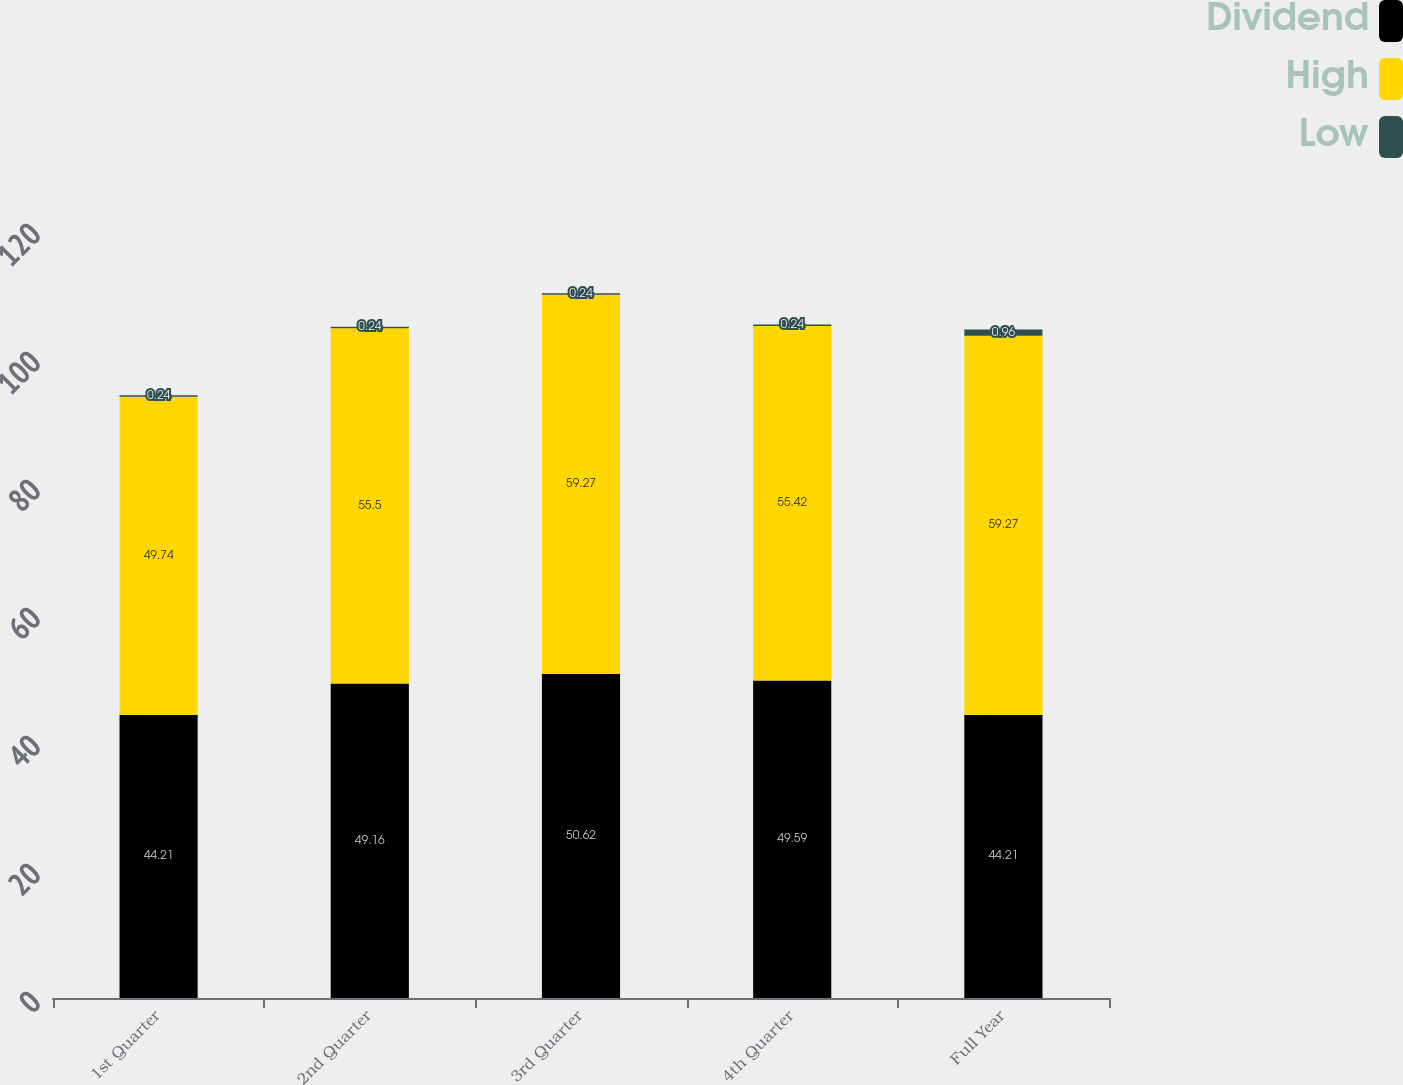Convert chart to OTSL. <chart><loc_0><loc_0><loc_500><loc_500><stacked_bar_chart><ecel><fcel>1st Quarter<fcel>2nd Quarter<fcel>3rd Quarter<fcel>4th Quarter<fcel>Full Year<nl><fcel>Dividend<fcel>44.21<fcel>49.16<fcel>50.62<fcel>49.59<fcel>44.21<nl><fcel>High<fcel>49.74<fcel>55.5<fcel>59.27<fcel>55.42<fcel>59.27<nl><fcel>Low<fcel>0.24<fcel>0.24<fcel>0.24<fcel>0.24<fcel>0.96<nl></chart> 